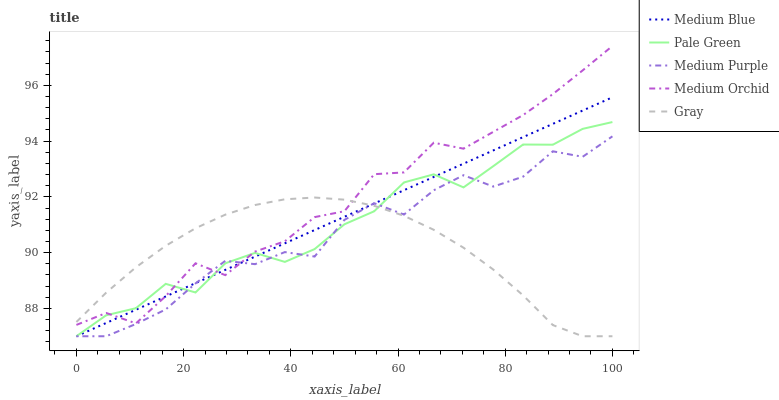Does Gray have the minimum area under the curve?
Answer yes or no. Yes. Does Medium Orchid have the maximum area under the curve?
Answer yes or no. Yes. Does Medium Orchid have the minimum area under the curve?
Answer yes or no. No. Does Gray have the maximum area under the curve?
Answer yes or no. No. Is Medium Blue the smoothest?
Answer yes or no. Yes. Is Medium Orchid the roughest?
Answer yes or no. Yes. Is Gray the smoothest?
Answer yes or no. No. Is Gray the roughest?
Answer yes or no. No. Does Medium Purple have the lowest value?
Answer yes or no. Yes. Does Medium Orchid have the lowest value?
Answer yes or no. No. Does Medium Orchid have the highest value?
Answer yes or no. Yes. Does Gray have the highest value?
Answer yes or no. No. Does Medium Purple intersect Pale Green?
Answer yes or no. Yes. Is Medium Purple less than Pale Green?
Answer yes or no. No. Is Medium Purple greater than Pale Green?
Answer yes or no. No. 